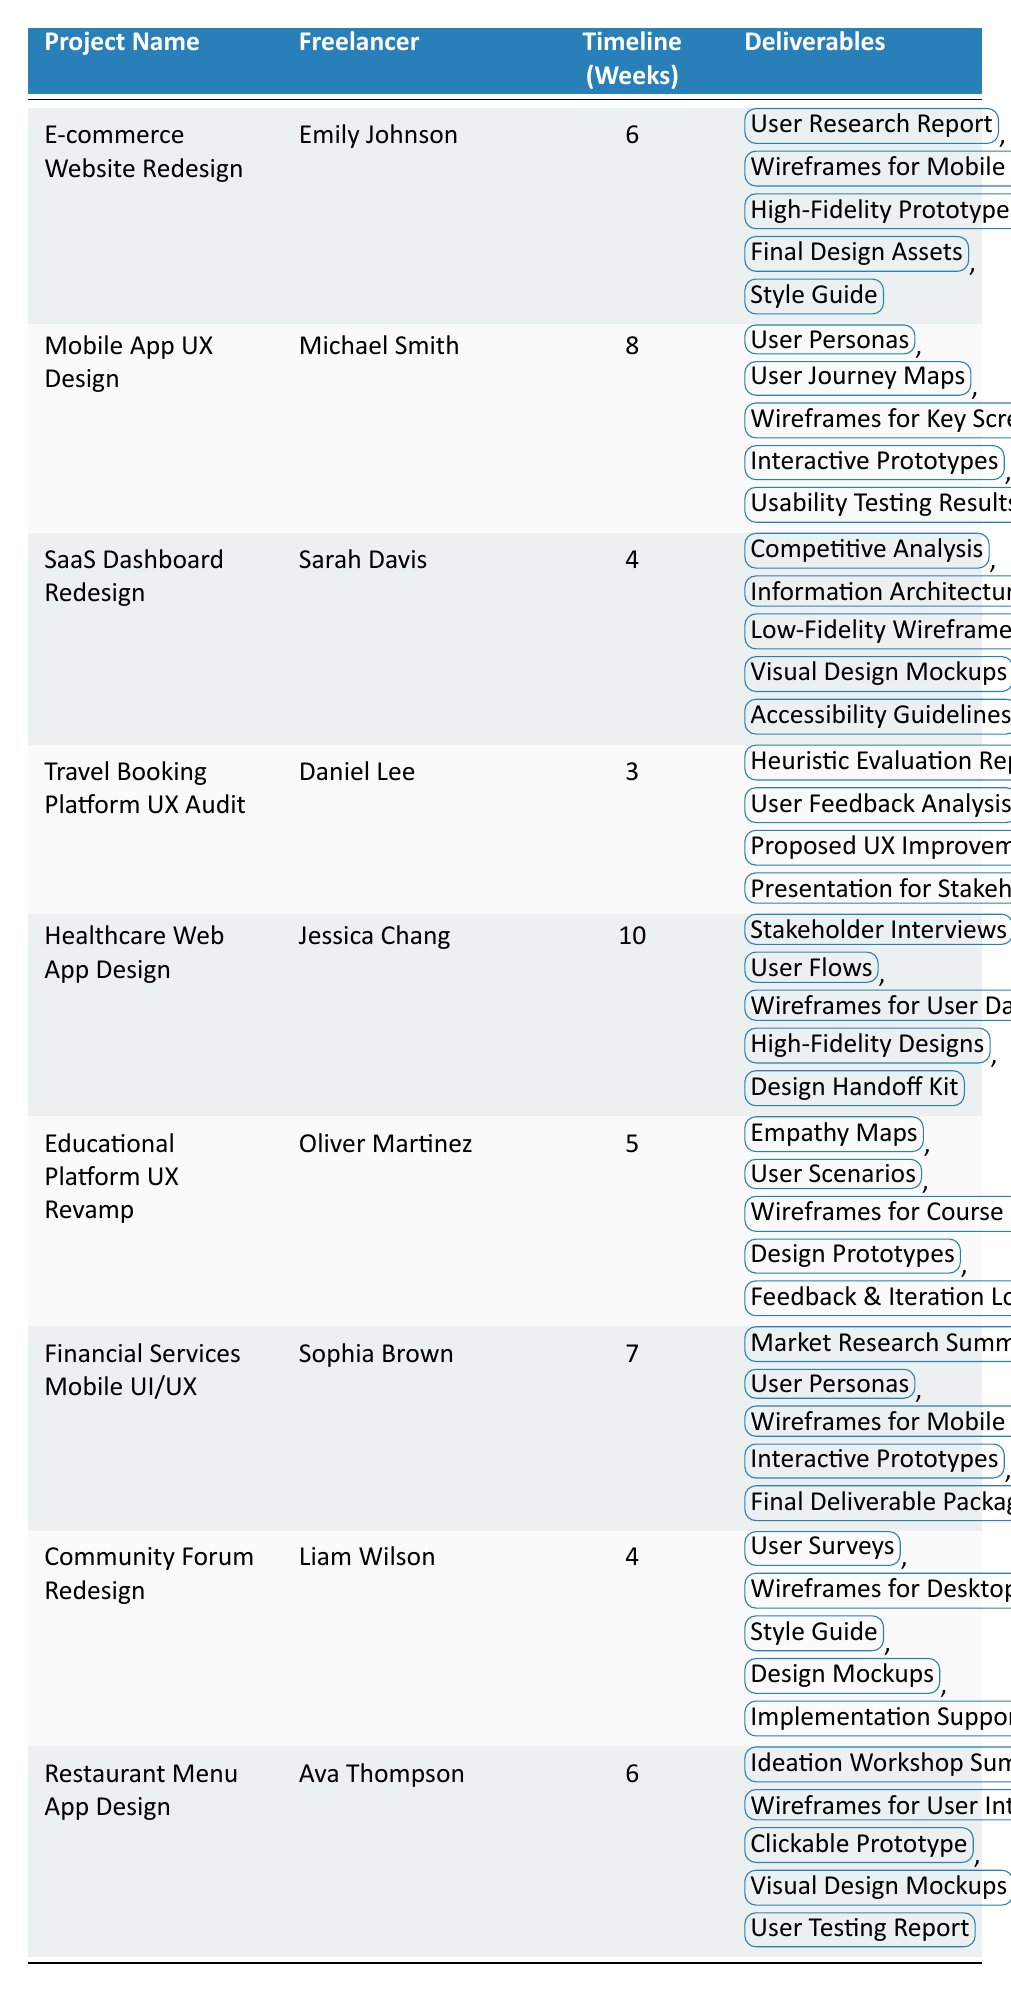What is the longest project timeline among the listed projects? The longest timeline indicated in the table is 10 weeks for the "Healthcare Web App Design" project by Jessica Chang.
Answer: 10 weeks Which freelancer worked on the "E-commerce Website Redesign"? The table specifies that Emily Johnson is the freelancer for the "E-commerce Website Redesign" project.
Answer: Emily Johnson How many projects have a timeline of 4 weeks? There are two projects listed with a timeline of 4 weeks: "SaaS Dashboard Redesign" by Sarah Davis and "Community Forum Redesign" by Liam Wilson.
Answer: 2 projects What are the deliverables for the "Mobile App UX Design" project? The deliverables for "Mobile App UX Design" by Michael Smith are: User Personas, User Journey Maps, Wireframes for Key Screens, Interactive Prototypes, and Usability Testing Results.
Answer: User Personas, User Journey Maps, Wireframes for Key Screens, Interactive Prototypes, Usability Testing Results Which project has the least amount of deliverables listed? The deliverables for the "Travel Booking Platform UX Audit" project, which has four deliverables, are fewer than any other project.
Answer: 4 deliverables Is there any project that includes "Wireframes for Mobile" as a deliverable? Yes, the "E-commerce Website Redesign" includes "Wireframes for Mobile & Desktop" in its deliverables.
Answer: Yes What is the average timeline for all the projects listed? The total timeline for all projects is 6 + 8 + 4 + 3 + 10 + 5 + 7 + 4 + 6 = 53 weeks. There are 9 projects, so the average is 53/9 = 5.89 weeks.
Answer: 5.89 weeks Which freelancer delivered a project with the shortest timeline, and what is that project's name? Daniel Lee completed the "Travel Booking Platform UX Audit" project with the shortest timeline of 3 weeks.
Answer: Daniel Lee; Travel Booking Platform UX Audit How many total deliverables are listed for the "Restaurant Menu App Design"? The project "Restaurant Menu App Design" by Ava Thompson lists five deliverables: Ideation Workshop Summary, Wireframes for User Interface, Clickable Prototype, Visual Design Mockups, and User Testing Report.
Answer: 5 deliverables Among the listed projects, which one contains “Design Handoff Kit” as a deliverable? The "Healthcare Web App Design" project by Jessica Chang includes "Design Handoff Kit" as one of its deliverables.
Answer: Healthcare Web App Design 